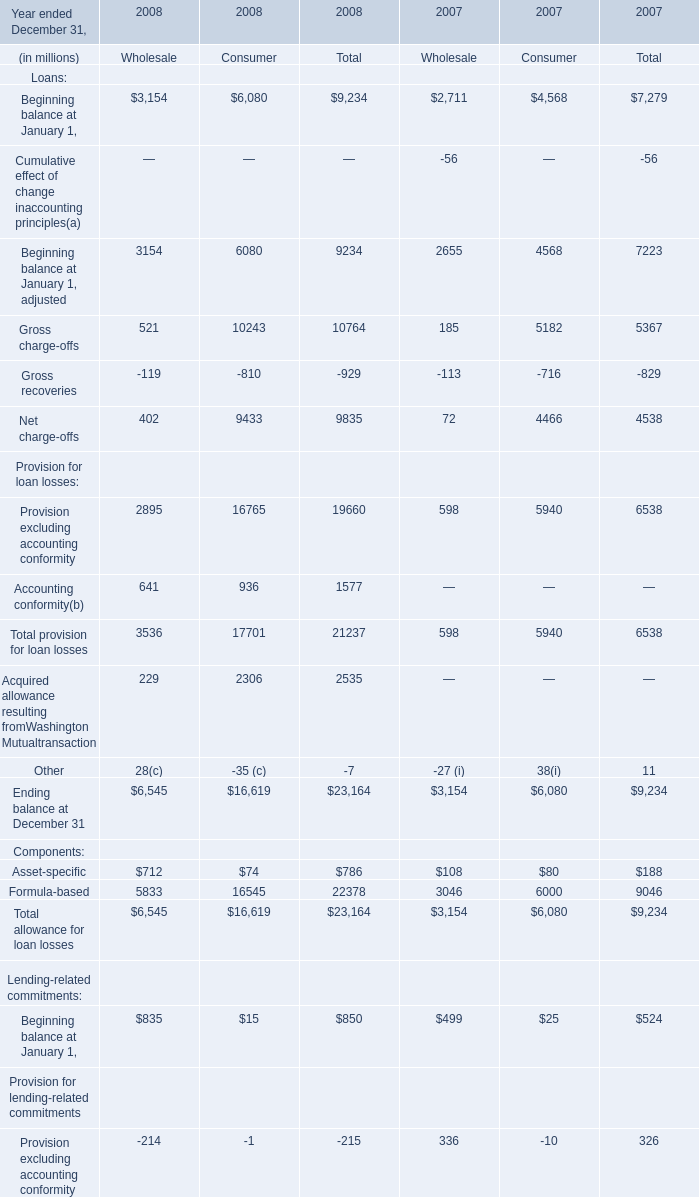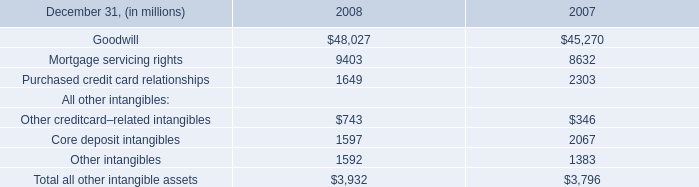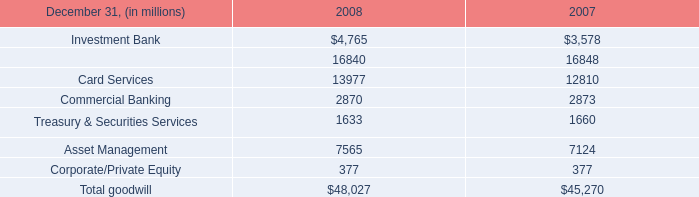What is the ratio of Gross charge-offs of Consumer in Table 0 to the Core deposit intangibles in Table 1 in 2008? 
Computations: (10243 / 1597)
Answer: 6.4139. 